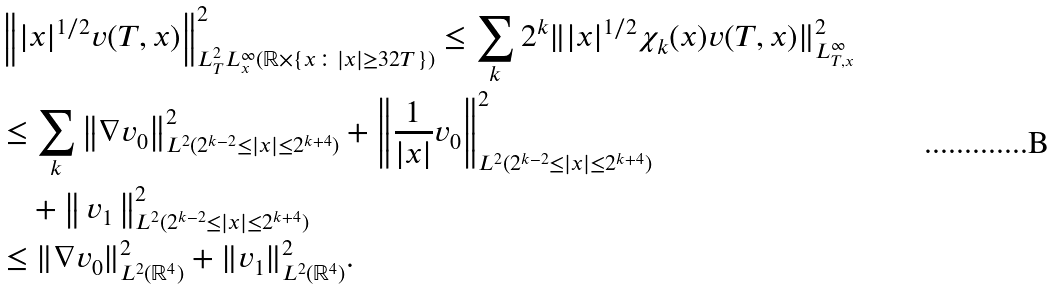<formula> <loc_0><loc_0><loc_500><loc_500>& \left \| | x | ^ { 1 / 2 } v ( T , x ) \right \| _ { L _ { T } ^ { 2 } L _ { x } ^ { \infty } ( \mathbb { R } \times \{ x \colon | x | \geq 3 2 T \} ) } ^ { 2 } \leq \sum _ { k } 2 ^ { k } \| | x | ^ { 1 / 2 } \chi _ { k } ( x ) v ( T , x ) \| _ { L _ { T , x } ^ { \infty } } ^ { 2 } \\ & \leq \sum _ { k } \left \| \nabla v _ { 0 } \right \| _ { L ^ { 2 } ( 2 ^ { k - 2 } \leq | x | \leq 2 ^ { k + 4 } ) } ^ { 2 } + \left \| \frac { 1 } { | x | } v _ { 0 } \right \| _ { L ^ { 2 } ( 2 ^ { k - 2 } \leq | x | \leq 2 ^ { k + 4 } ) } ^ { 2 } \\ & \quad + \left \| \, v _ { 1 } \, \right \| _ { L ^ { 2 } ( 2 ^ { k - 2 } \leq | x | \leq 2 ^ { k + 4 } ) } ^ { 2 } \\ & \leq \| \nabla v _ { 0 } \| _ { L ^ { 2 } ( \mathbb { R } ^ { 4 } ) } ^ { 2 } + \| v _ { 1 } \| _ { L ^ { 2 } ( \mathbb { R } ^ { 4 } ) } ^ { 2 } .</formula> 